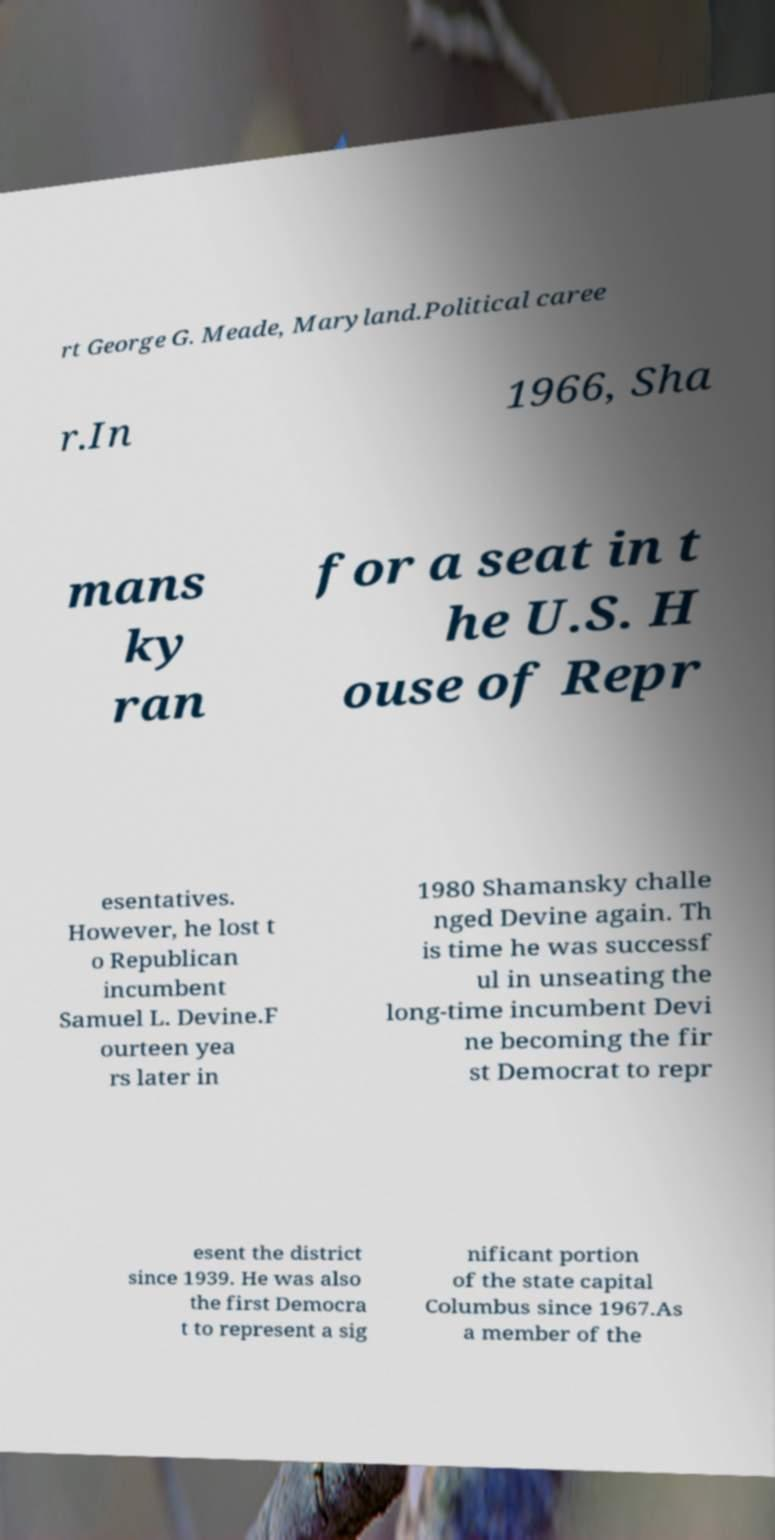I need the written content from this picture converted into text. Can you do that? rt George G. Meade, Maryland.Political caree r.In 1966, Sha mans ky ran for a seat in t he U.S. H ouse of Repr esentatives. However, he lost t o Republican incumbent Samuel L. Devine.F ourteen yea rs later in 1980 Shamansky challe nged Devine again. Th is time he was successf ul in unseating the long-time incumbent Devi ne becoming the fir st Democrat to repr esent the district since 1939. He was also the first Democra t to represent a sig nificant portion of the state capital Columbus since 1967.As a member of the 